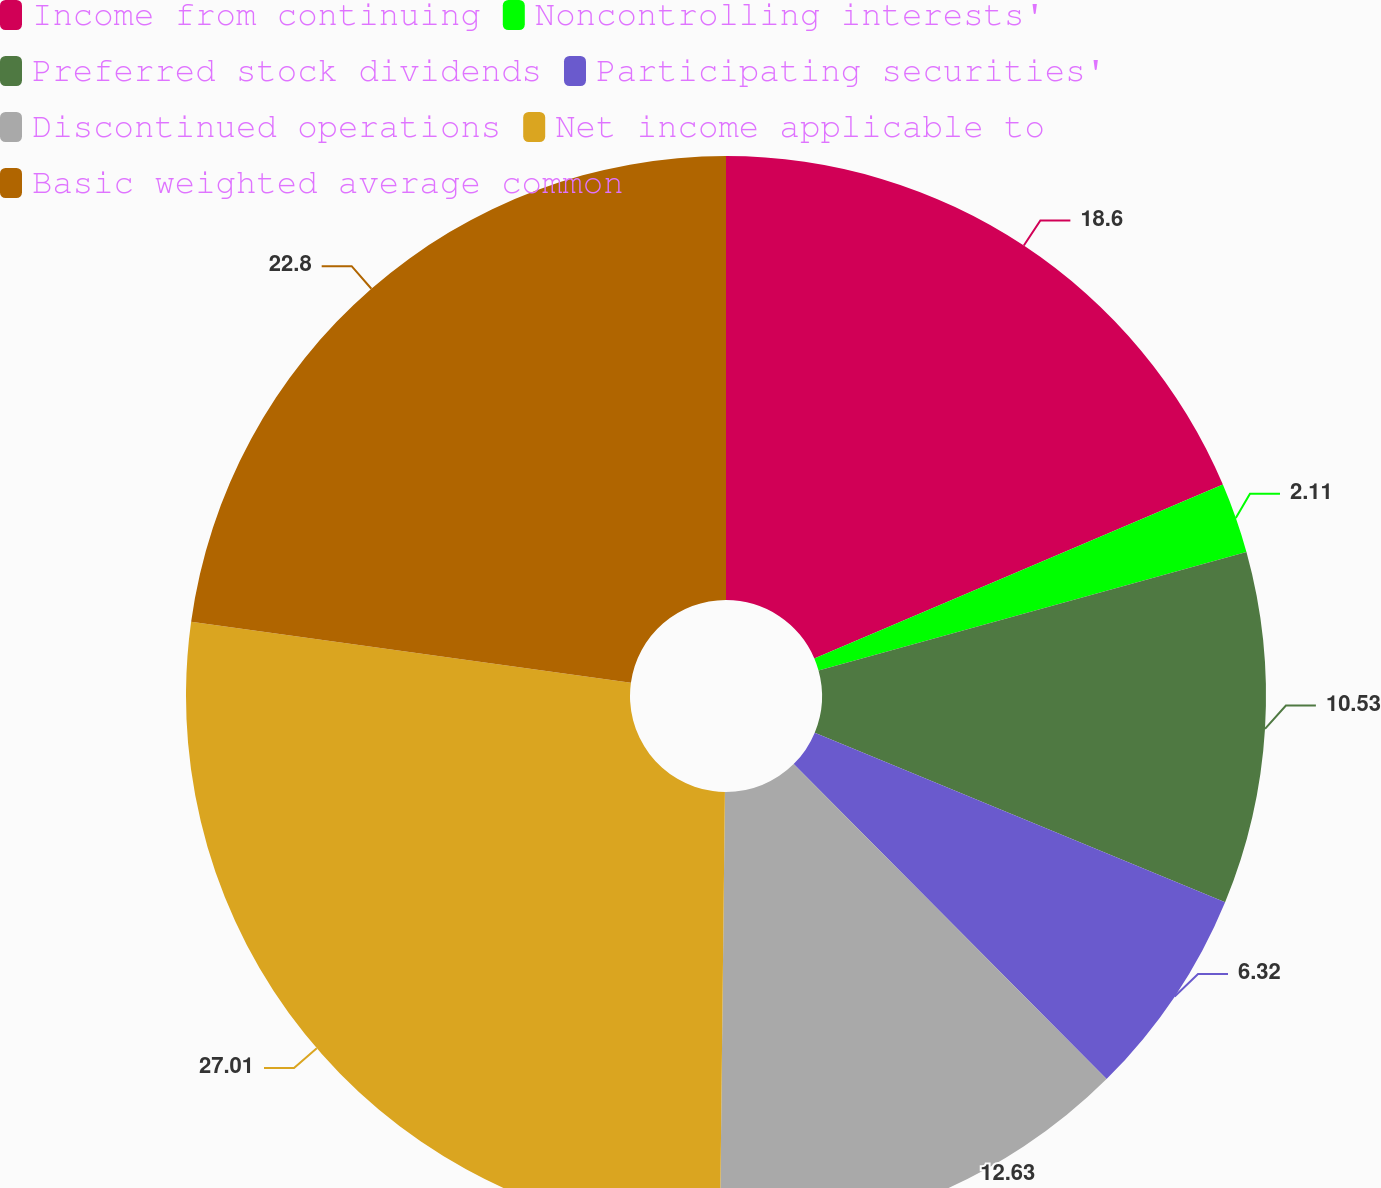<chart> <loc_0><loc_0><loc_500><loc_500><pie_chart><fcel>Income from continuing<fcel>Noncontrolling interests'<fcel>Preferred stock dividends<fcel>Participating securities'<fcel>Discontinued operations<fcel>Net income applicable to<fcel>Basic weighted average common<nl><fcel>18.6%<fcel>2.11%<fcel>10.53%<fcel>6.32%<fcel>12.63%<fcel>27.02%<fcel>22.81%<nl></chart> 